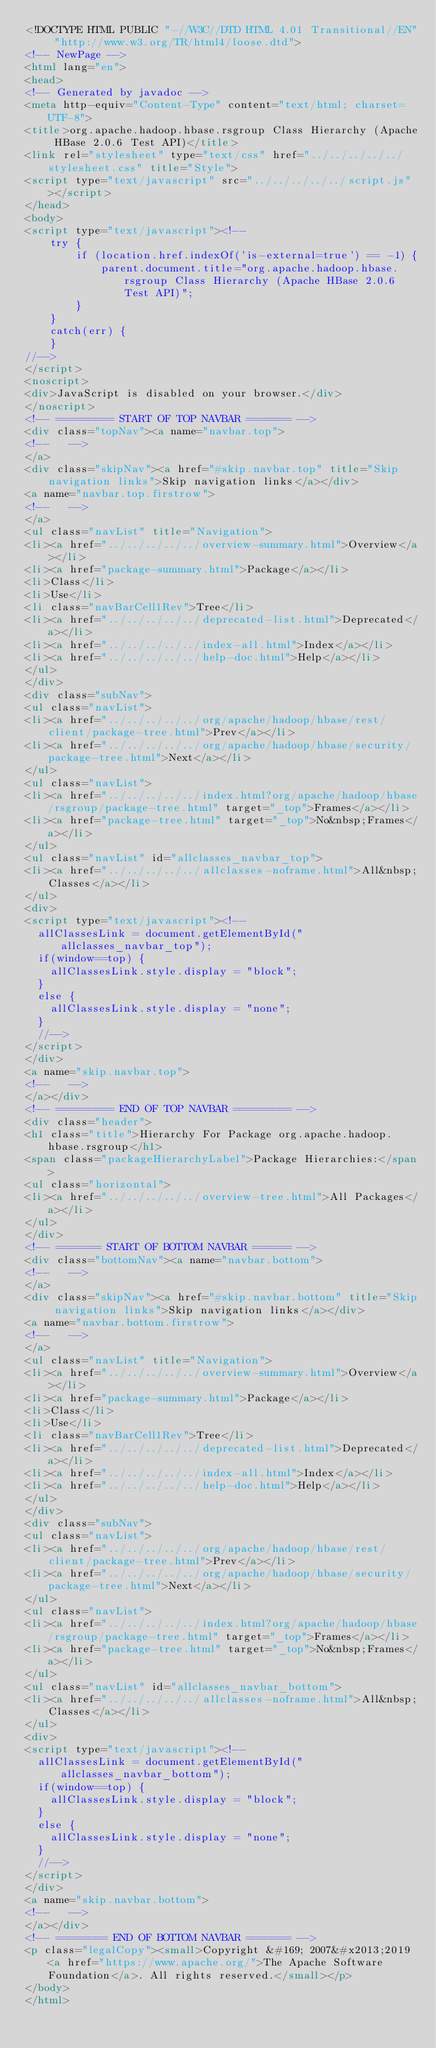Convert code to text. <code><loc_0><loc_0><loc_500><loc_500><_HTML_><!DOCTYPE HTML PUBLIC "-//W3C//DTD HTML 4.01 Transitional//EN" "http://www.w3.org/TR/html4/loose.dtd">
<!-- NewPage -->
<html lang="en">
<head>
<!-- Generated by javadoc -->
<meta http-equiv="Content-Type" content="text/html; charset=UTF-8">
<title>org.apache.hadoop.hbase.rsgroup Class Hierarchy (Apache HBase 2.0.6 Test API)</title>
<link rel="stylesheet" type="text/css" href="../../../../../stylesheet.css" title="Style">
<script type="text/javascript" src="../../../../../script.js"></script>
</head>
<body>
<script type="text/javascript"><!--
    try {
        if (location.href.indexOf('is-external=true') == -1) {
            parent.document.title="org.apache.hadoop.hbase.rsgroup Class Hierarchy (Apache HBase 2.0.6 Test API)";
        }
    }
    catch(err) {
    }
//-->
</script>
<noscript>
<div>JavaScript is disabled on your browser.</div>
</noscript>
<!-- ========= START OF TOP NAVBAR ======= -->
<div class="topNav"><a name="navbar.top">
<!--   -->
</a>
<div class="skipNav"><a href="#skip.navbar.top" title="Skip navigation links">Skip navigation links</a></div>
<a name="navbar.top.firstrow">
<!--   -->
</a>
<ul class="navList" title="Navigation">
<li><a href="../../../../../overview-summary.html">Overview</a></li>
<li><a href="package-summary.html">Package</a></li>
<li>Class</li>
<li>Use</li>
<li class="navBarCell1Rev">Tree</li>
<li><a href="../../../../../deprecated-list.html">Deprecated</a></li>
<li><a href="../../../../../index-all.html">Index</a></li>
<li><a href="../../../../../help-doc.html">Help</a></li>
</ul>
</div>
<div class="subNav">
<ul class="navList">
<li><a href="../../../../../org/apache/hadoop/hbase/rest/client/package-tree.html">Prev</a></li>
<li><a href="../../../../../org/apache/hadoop/hbase/security/package-tree.html">Next</a></li>
</ul>
<ul class="navList">
<li><a href="../../../../../index.html?org/apache/hadoop/hbase/rsgroup/package-tree.html" target="_top">Frames</a></li>
<li><a href="package-tree.html" target="_top">No&nbsp;Frames</a></li>
</ul>
<ul class="navList" id="allclasses_navbar_top">
<li><a href="../../../../../allclasses-noframe.html">All&nbsp;Classes</a></li>
</ul>
<div>
<script type="text/javascript"><!--
  allClassesLink = document.getElementById("allclasses_navbar_top");
  if(window==top) {
    allClassesLink.style.display = "block";
  }
  else {
    allClassesLink.style.display = "none";
  }
  //-->
</script>
</div>
<a name="skip.navbar.top">
<!--   -->
</a></div>
<!-- ========= END OF TOP NAVBAR ========= -->
<div class="header">
<h1 class="title">Hierarchy For Package org.apache.hadoop.hbase.rsgroup</h1>
<span class="packageHierarchyLabel">Package Hierarchies:</span>
<ul class="horizontal">
<li><a href="../../../../../overview-tree.html">All Packages</a></li>
</ul>
</div>
<!-- ======= START OF BOTTOM NAVBAR ====== -->
<div class="bottomNav"><a name="navbar.bottom">
<!--   -->
</a>
<div class="skipNav"><a href="#skip.navbar.bottom" title="Skip navigation links">Skip navigation links</a></div>
<a name="navbar.bottom.firstrow">
<!--   -->
</a>
<ul class="navList" title="Navigation">
<li><a href="../../../../../overview-summary.html">Overview</a></li>
<li><a href="package-summary.html">Package</a></li>
<li>Class</li>
<li>Use</li>
<li class="navBarCell1Rev">Tree</li>
<li><a href="../../../../../deprecated-list.html">Deprecated</a></li>
<li><a href="../../../../../index-all.html">Index</a></li>
<li><a href="../../../../../help-doc.html">Help</a></li>
</ul>
</div>
<div class="subNav">
<ul class="navList">
<li><a href="../../../../../org/apache/hadoop/hbase/rest/client/package-tree.html">Prev</a></li>
<li><a href="../../../../../org/apache/hadoop/hbase/security/package-tree.html">Next</a></li>
</ul>
<ul class="navList">
<li><a href="../../../../../index.html?org/apache/hadoop/hbase/rsgroup/package-tree.html" target="_top">Frames</a></li>
<li><a href="package-tree.html" target="_top">No&nbsp;Frames</a></li>
</ul>
<ul class="navList" id="allclasses_navbar_bottom">
<li><a href="../../../../../allclasses-noframe.html">All&nbsp;Classes</a></li>
</ul>
<div>
<script type="text/javascript"><!--
  allClassesLink = document.getElementById("allclasses_navbar_bottom");
  if(window==top) {
    allClassesLink.style.display = "block";
  }
  else {
    allClassesLink.style.display = "none";
  }
  //-->
</script>
</div>
<a name="skip.navbar.bottom">
<!--   -->
</a></div>
<!-- ======== END OF BOTTOM NAVBAR ======= -->
<p class="legalCopy"><small>Copyright &#169; 2007&#x2013;2019 <a href="https://www.apache.org/">The Apache Software Foundation</a>. All rights reserved.</small></p>
</body>
</html>
</code> 